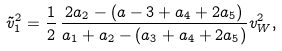<formula> <loc_0><loc_0><loc_500><loc_500>\tilde { v } ^ { 2 } _ { 1 } = \frac { 1 } { 2 } \, \frac { 2 a _ { 2 } - ( a - 3 + a _ { 4 } + 2 a _ { 5 } ) } { a _ { 1 } + a _ { 2 } - ( a _ { 3 } + a _ { 4 } + 2 a _ { 5 } ) } v ^ { 2 } _ { W } ,</formula> 